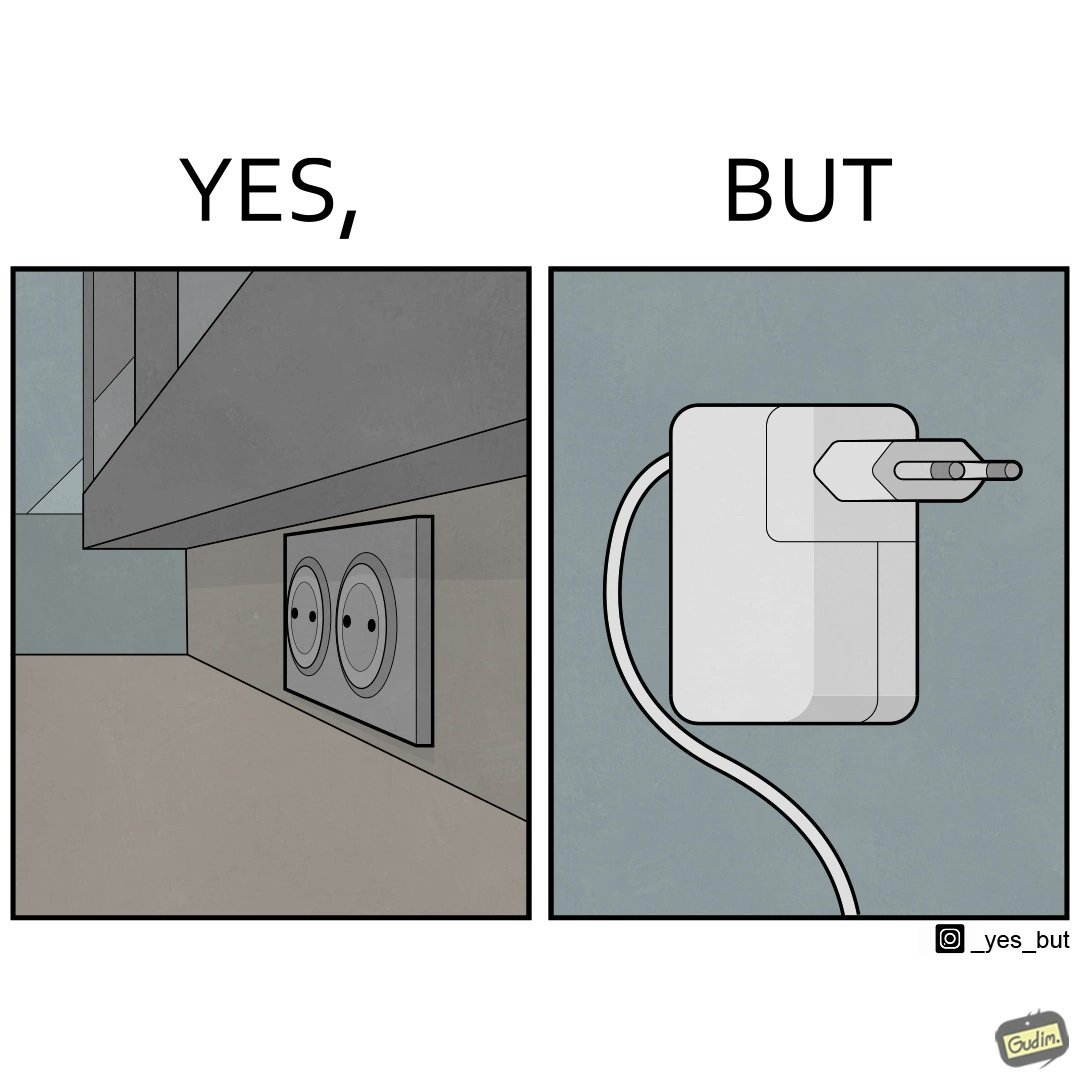Is this a satirical image? Yes, this image is satirical. 